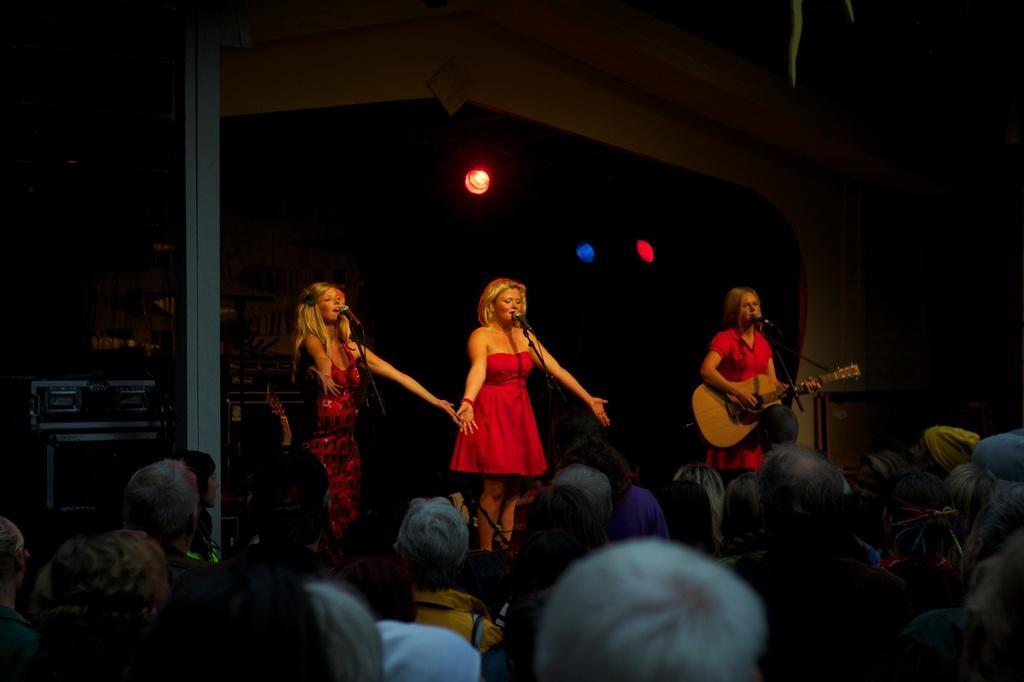Could you give a brief overview of what you see in this image? There are three women standing on the stage. Two of them were singing in front of a microphones and stands. Another woman is playing guitar in her hands and singing. There are some people standing and watching their performance. In the background there is a light. 